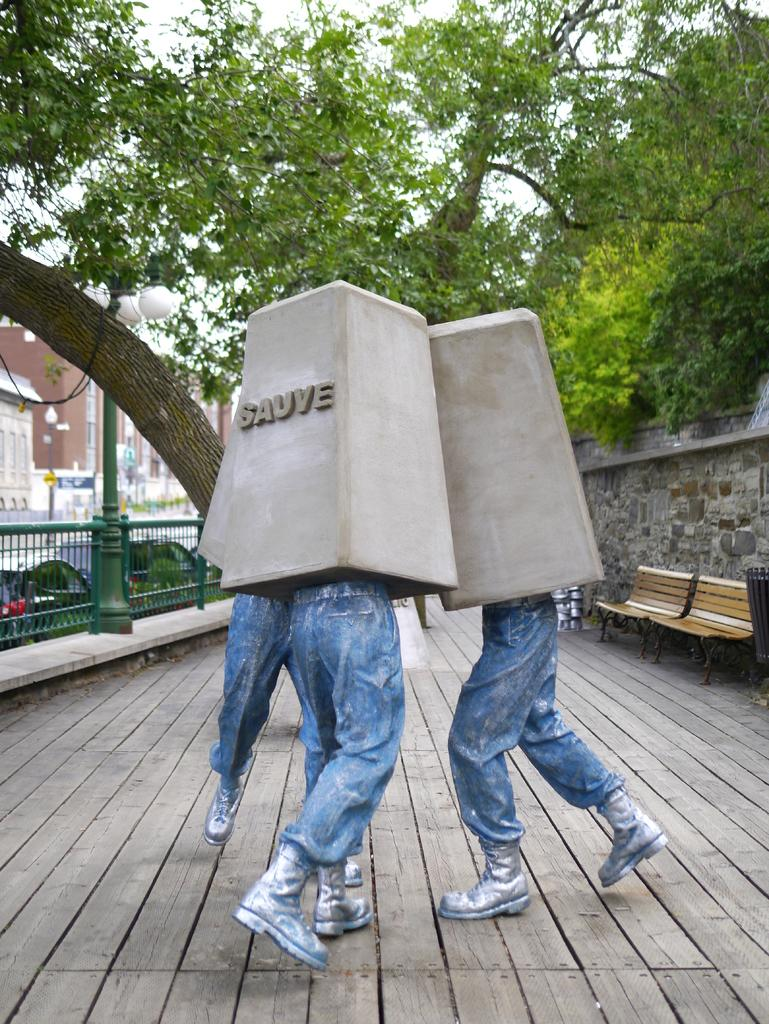What is the main subject in the center of the image? There are statues in the center of the image. What can be seen in the background of the image? There are trees, benches, buildings, and a light in the background of the image. What type of stone is the statue made of in the image? The provided facts do not mention the material of the statues, so we cannot determine the type of stone used. Can you describe the horn on the statue in the image? There is no horn present on the statues in the image. 